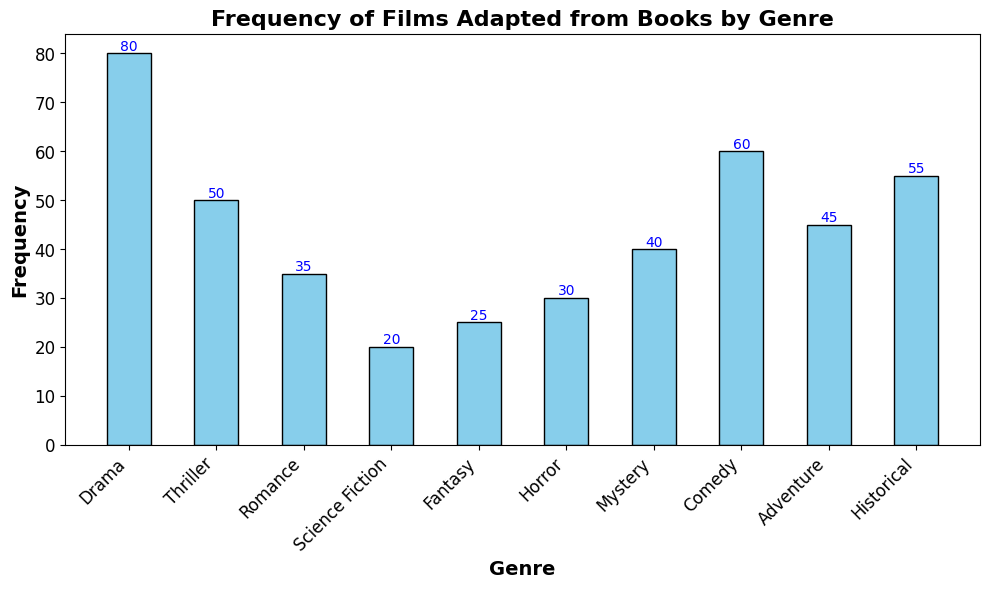What genre has the highest frequency of films adapted from books? Look at the heights of the bars and find the tallest one. The Drama bar is the highest at 80.
Answer: Drama Which genre has the lowest frequency of films adapted from books? Identify the shortest bar in the histogram. The Science Fiction bar is the shortest at 20.
Answer: Science Fiction Is the frequency of films adapted from books in the Thriller genre greater than in the Comedy genre? Compare the heights of the bars for Thriller (50) and Comedy (60). Since 50 is less than 60, Thriller is less.
Answer: No How much more frequent are Drama adaptations compared to Romance adaptations? Subtract the Romance frequency (35) from the Drama frequency (80). 80 - 35 = 45.
Answer: 45 What is the total frequency of films adapted from books in the Fantasy and Historical genres combined? Add the frequencies of Fantasy (25) and Historical (55). 25 + 55 = 80.
Answer: 80 Which genre has a frequency that is equal to the average of Science Fiction and Horror frequencies? First, calculate the average of Science Fiction (20) and Horror (30). (20 + 30) / 2 = 25. Then, look for the genre with a frequency of 25, which is Fantasy.
Answer: Fantasy Compare the frequency of films adapted from books in the Adventure genre to the Mystery genre. Which genre has a higher frequency? Look at the heights of the bars for Adventure (45) and Mystery (40). Adventure's bar is higher.
Answer: Adventure Are there more Comedy genre adaptations or Thriller genre adaptations? By how much? Compare the bars of Comedy (60) and Thriller (50). Since Comedy is taller, subtract Thriller from Comedy. 60 - 50 = 10.
Answer: Comedy; 10 What is the sum of the frequencies for all genres depicted in the histogram? Add up all the frequencies: 80 + 50 + 35 + 20 + 25 + 30 + 40 + 60 + 45 + 55 = 440.
Answer: 440 